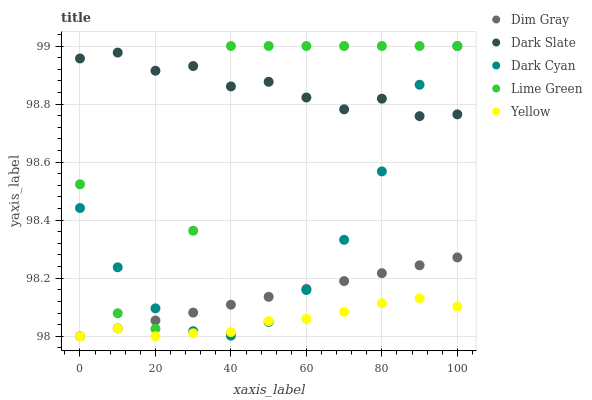Does Yellow have the minimum area under the curve?
Answer yes or no. Yes. Does Dark Slate have the maximum area under the curve?
Answer yes or no. Yes. Does Dim Gray have the minimum area under the curve?
Answer yes or no. No. Does Dim Gray have the maximum area under the curve?
Answer yes or no. No. Is Dim Gray the smoothest?
Answer yes or no. Yes. Is Lime Green the roughest?
Answer yes or no. Yes. Is Dark Slate the smoothest?
Answer yes or no. No. Is Dark Slate the roughest?
Answer yes or no. No. Does Dim Gray have the lowest value?
Answer yes or no. Yes. Does Dark Slate have the lowest value?
Answer yes or no. No. Does Lime Green have the highest value?
Answer yes or no. Yes. Does Dark Slate have the highest value?
Answer yes or no. No. Is Dim Gray less than Dark Slate?
Answer yes or no. Yes. Is Dark Slate greater than Yellow?
Answer yes or no. Yes. Does Lime Green intersect Dim Gray?
Answer yes or no. Yes. Is Lime Green less than Dim Gray?
Answer yes or no. No. Is Lime Green greater than Dim Gray?
Answer yes or no. No. Does Dim Gray intersect Dark Slate?
Answer yes or no. No. 